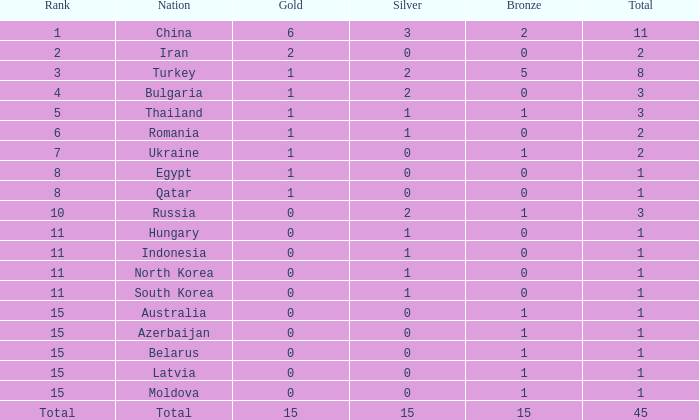What is the highest amount of bronze china, which has more than 1 gold and more than 11 total, has? None. 